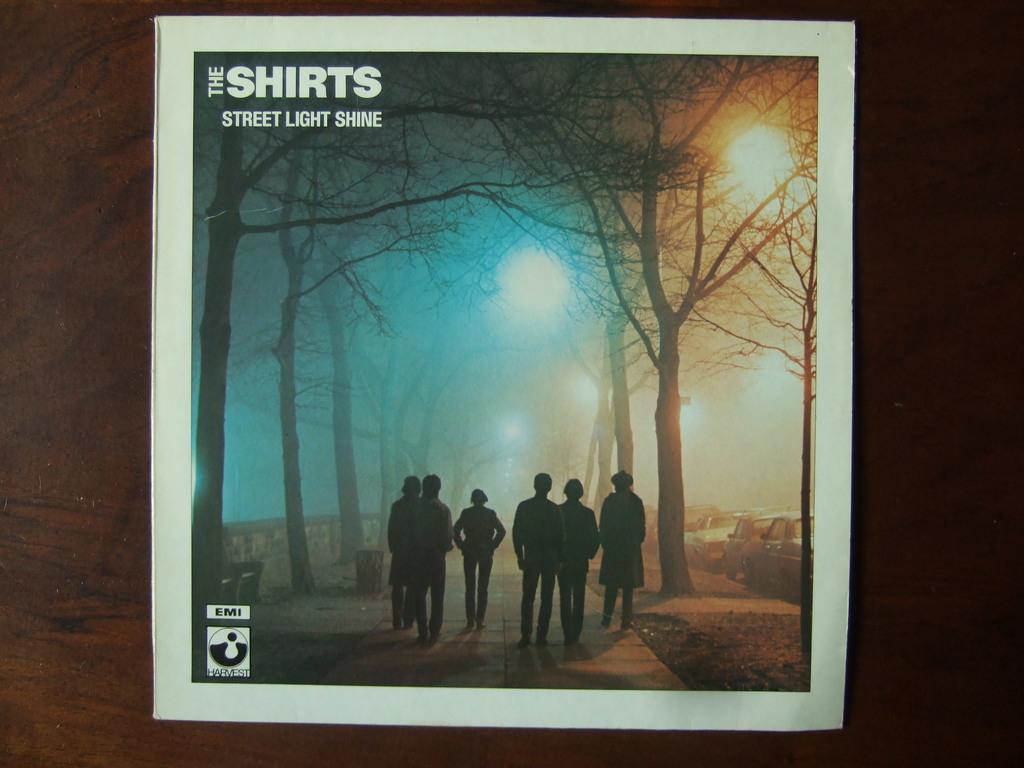In one or two sentences, can you explain what this image depicts? In this picture, we see six men are walking on the road. On either side of the road, we see trees. On the right side, there are cars parked on the road. On the left side, we see a wall. We see the street lights. This might be a photo frame. In the background, it is brown in color. 